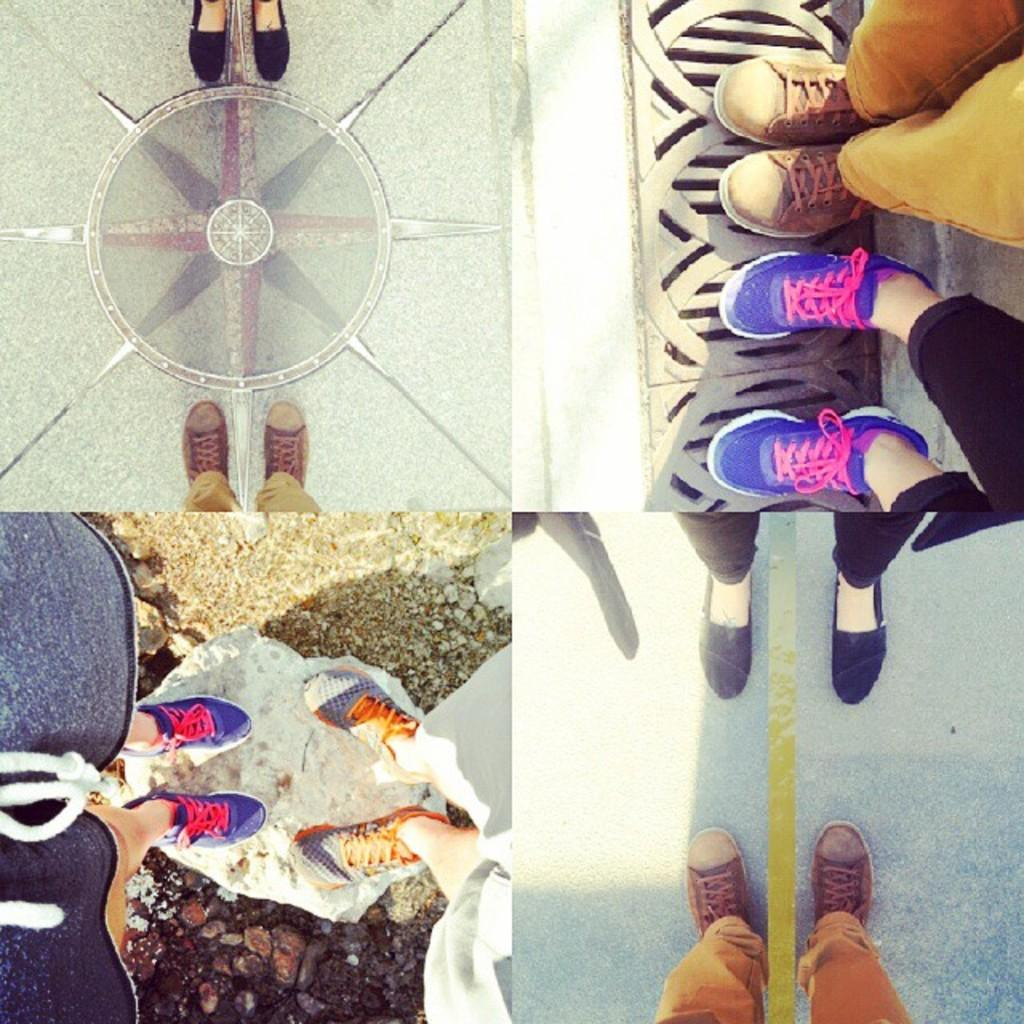What type of image is being described? The image is a collage. What part of the human body can be seen in the image? A: People's legs are visible in the image. What type of rock is being worn as a badge in the image? There is no rock or badge present in the image; it only features people's legs in a collage. 